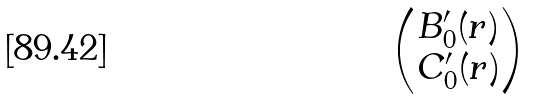<formula> <loc_0><loc_0><loc_500><loc_500>\begin{pmatrix} B _ { 0 } ^ { \prime } ( r ) \\ C _ { 0 } ^ { \prime } ( r ) \end{pmatrix}</formula> 